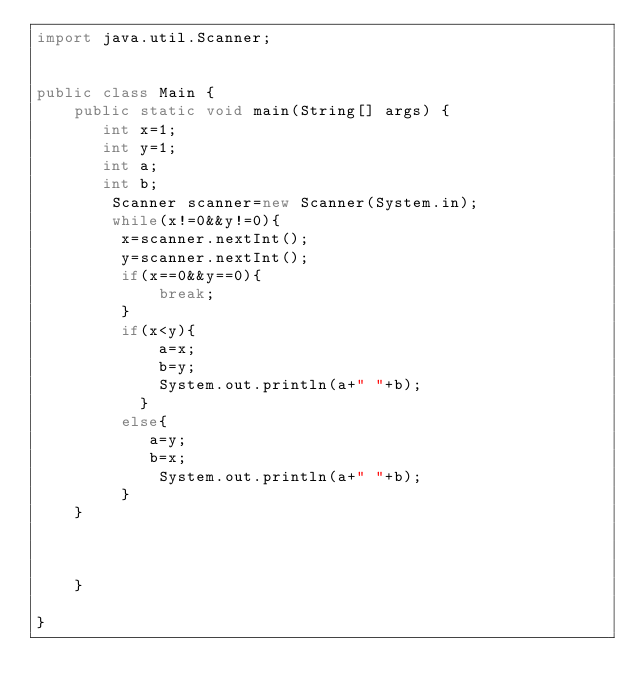Convert code to text. <code><loc_0><loc_0><loc_500><loc_500><_Java_>import java.util.Scanner;


public class Main {
    public static void main(String[] args) {
       int x=1;
       int y=1;
       int a;
       int b;
        Scanner scanner=new Scanner(System.in);
        while(x!=0&&y!=0){
         x=scanner.nextInt();
         y=scanner.nextInt();
         if(x==0&&y==0){
             break;
         }
         if(x<y){
             a=x;
             b=y;
             System.out.println(a+" "+b);
           }
         else{
            a=y;
            b=x;
             System.out.println(a+" "+b);
         }
    }
        
        
                
    }

}</code> 